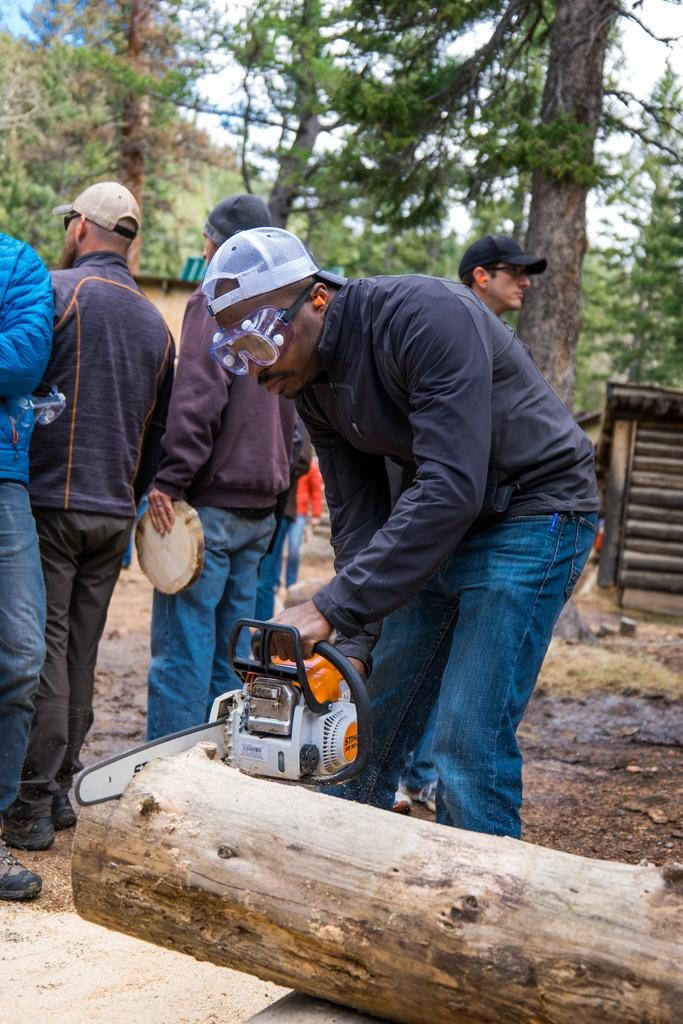How many people are in the image? There are people in the image, but the exact number is not specified. What are some people doing in the image? Some people are holding objects in the image. What type of surface can be seen under the people's feet? The ground is visible in the image. What type of objects can be seen in the image? There are wooden objects in the image. What type of natural environment is visible in the image? Trees are present in the image, indicating a natural environment. What part of the sky is visible in the image? The sky is visible in the image. Can you see any mountains in the image? There is no mention of mountains in the image, so we cannot say if they are present or not. What type of quill is being used by the people in the image? There is no mention of a quill in the image, so we cannot say if it is being used or not. 